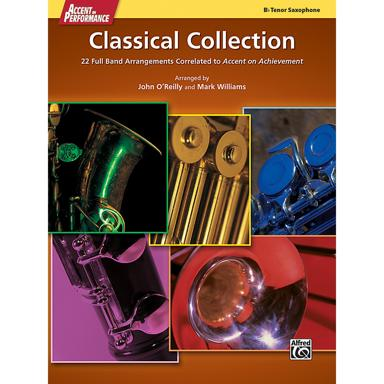Is this collection suitable for beginners or more advanced players? Given the correlation with 'Accent on Achievement', which is designed to nurture beginning to intermediate-level players, this collection is likely best suited for those at a similar skill level. It can serve as a practical stepping stone for students transitioning from basic techniques to more sophisticated classical pieces. 